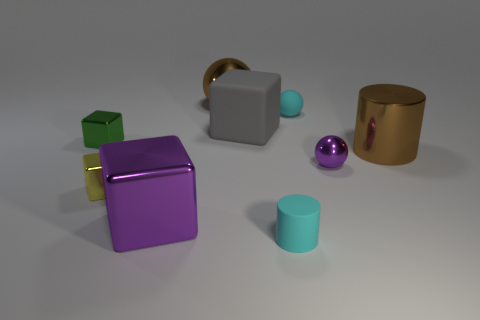Add 1 small yellow matte cubes. How many objects exist? 10 Subtract all cylinders. How many objects are left? 7 Subtract 0 red cubes. How many objects are left? 9 Subtract all shiny cubes. Subtract all small green cubes. How many objects are left? 5 Add 6 big purple metallic blocks. How many big purple metallic blocks are left? 7 Add 7 gray cylinders. How many gray cylinders exist? 7 